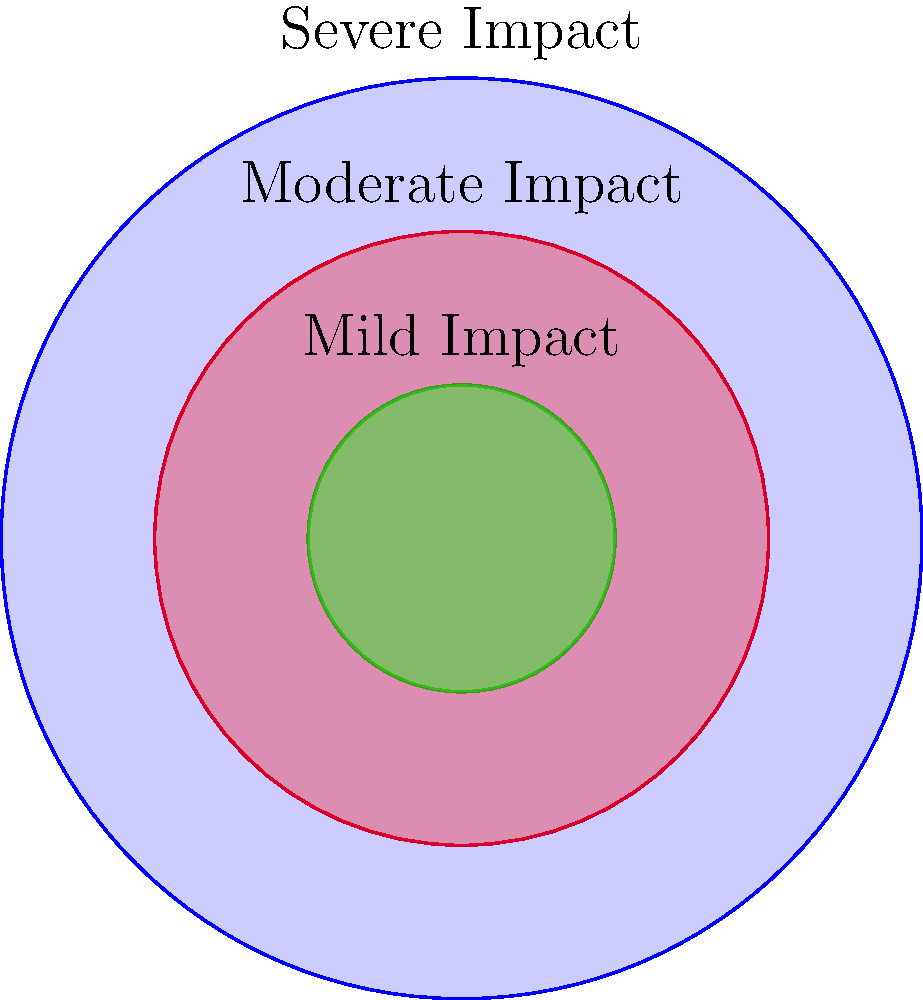In a conflict zone, the impact on children's health is represented by concentric circles. The outer circle (radius 3 units) represents severe impact, the middle circle (radius 2 units) represents moderate impact, and the inner circle (radius 1 unit) represents mild impact. Calculate the area of the region representing moderate to severe impact (i.e., the area between the inner and outer circles). To find the area of the region representing moderate to severe impact, we need to:

1. Calculate the area of the outer circle (severe impact):
   $A_1 = \pi r_1^2 = \pi (3^2) = 9\pi$

2. Calculate the area of the inner circle (mild impact):
   $A_2 = \pi r_3^2 = \pi (1^2) = \pi$

3. Subtract the area of the inner circle from the area of the outer circle:
   $A_{moderate\,to\,severe} = A_1 - A_2 = 9\pi - \pi = 8\pi$

Therefore, the area representing moderate to severe impact on children's health in the conflict zone is $8\pi$ square units.
Answer: $8\pi$ square units 